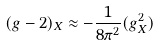<formula> <loc_0><loc_0><loc_500><loc_500>( g - 2 ) _ { X } \approx - \frac { 1 } { 8 \pi ^ { 2 } } ( g ^ { 2 } _ { X } )</formula> 